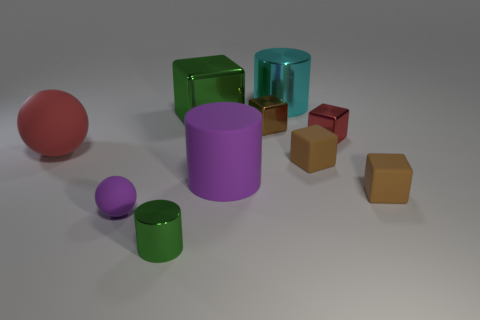How many green metal cubes are the same size as the red shiny block?
Provide a succinct answer. 0. Is the red metal thing the same size as the cyan cylinder?
Provide a succinct answer. No. What size is the cylinder that is both to the right of the small cylinder and in front of the large green cube?
Keep it short and to the point. Large. Is the number of tiny cylinders that are to the left of the green block greater than the number of small balls that are right of the brown metallic cube?
Your answer should be very brief. Yes. There is a large rubber object that is the same shape as the small green thing; what is its color?
Keep it short and to the point. Purple. Does the large rubber cylinder that is on the right side of the small rubber sphere have the same color as the small sphere?
Your answer should be very brief. Yes. How many brown rubber cubes are there?
Make the answer very short. 2. Are the big thing to the left of the tiny cylinder and the big cube made of the same material?
Provide a short and direct response. No. There is a big cylinder in front of the big cylinder that is behind the big red thing; how many shiny cubes are right of it?
Your answer should be very brief. 2. The red cube is what size?
Provide a succinct answer. Small. 